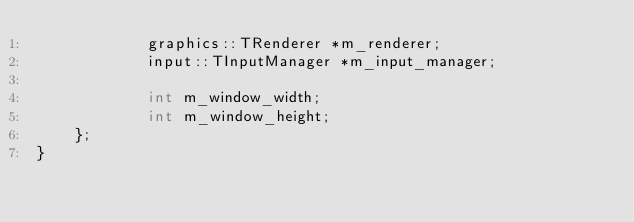<code> <loc_0><loc_0><loc_500><loc_500><_C_>            graphics::TRenderer *m_renderer;
            input::TInputManager *m_input_manager;

            int m_window_width;
            int m_window_height;
    };
}
</code> 